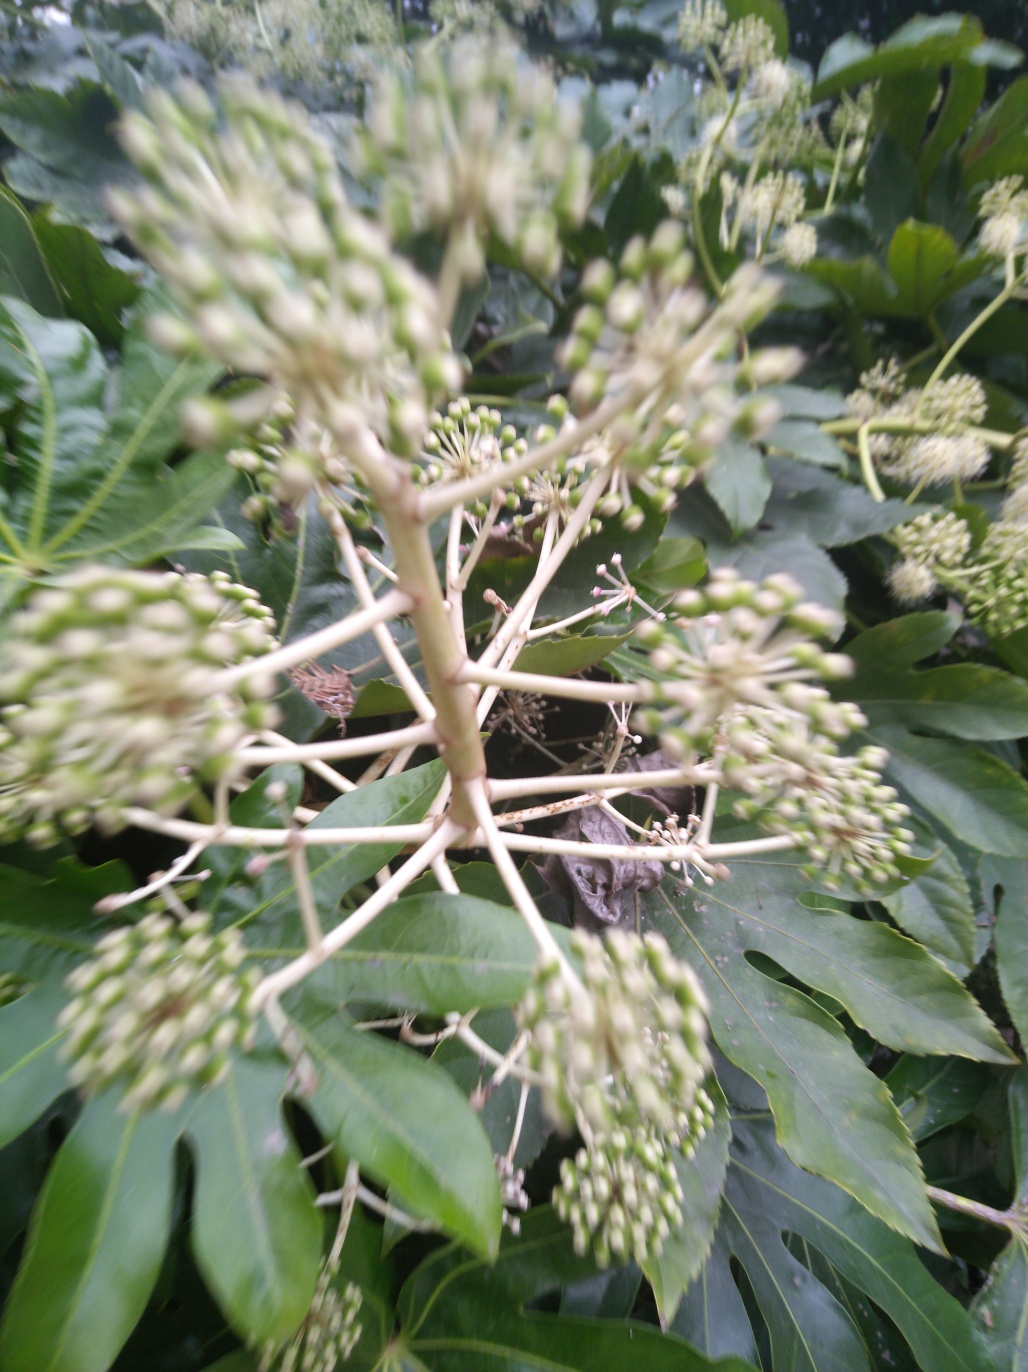Can you suggest a real-world scenario where this level of motion blur might be intentional? Certainly, photographers sometimes use motion blur intentionally to convey speed or the passage of time, such as in sports photography or to show the hustle and bustle of city life. In artistic photography, motion blur can be employed to create a dreamy or ethereal effect that gives the image a sense of being fleeting or impermanent. 